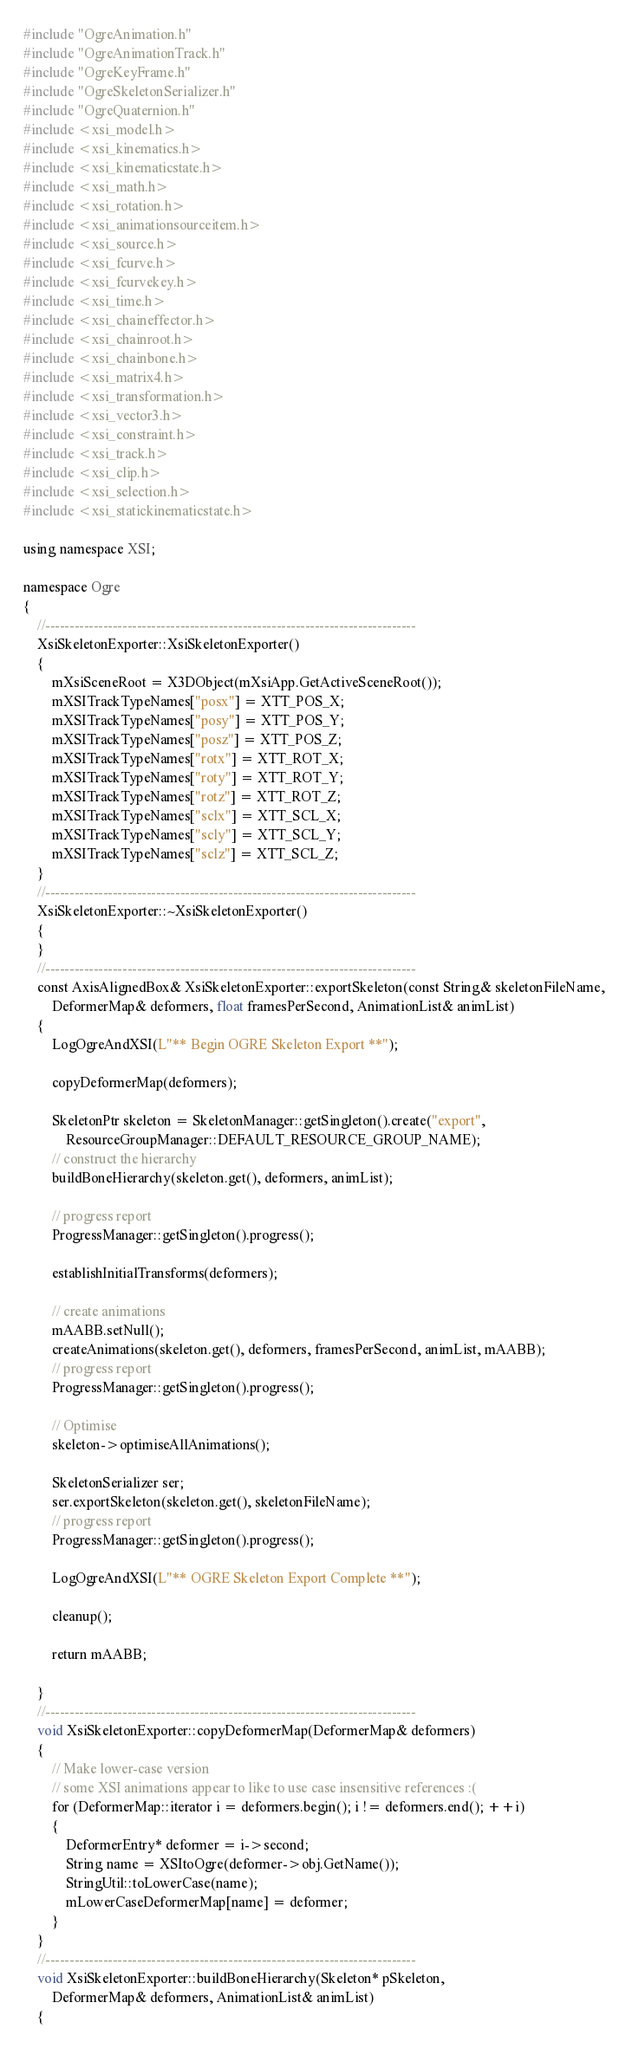Convert code to text. <code><loc_0><loc_0><loc_500><loc_500><_C++_>#include "OgreAnimation.h"
#include "OgreAnimationTrack.h"
#include "OgreKeyFrame.h"
#include "OgreSkeletonSerializer.h"
#include "OgreQuaternion.h"
#include <xsi_model.h>
#include <xsi_kinematics.h>
#include <xsi_kinematicstate.h>
#include <xsi_math.h>
#include <xsi_rotation.h>
#include <xsi_animationsourceitem.h>
#include <xsi_source.h>
#include <xsi_fcurve.h>
#include <xsi_fcurvekey.h>
#include <xsi_time.h>
#include <xsi_chaineffector.h>
#include <xsi_chainroot.h>
#include <xsi_chainbone.h>
#include <xsi_matrix4.h>
#include <xsi_transformation.h>
#include <xsi_vector3.h>
#include <xsi_constraint.h>
#include <xsi_track.h>
#include <xsi_clip.h>
#include <xsi_selection.h>
#include <xsi_statickinematicstate.h>

using namespace XSI;

namespace Ogre
{
	//-----------------------------------------------------------------------------
	XsiSkeletonExporter::XsiSkeletonExporter()
	{
		mXsiSceneRoot = X3DObject(mXsiApp.GetActiveSceneRoot());
		mXSITrackTypeNames["posx"] = XTT_POS_X;
		mXSITrackTypeNames["posy"] = XTT_POS_Y;
		mXSITrackTypeNames["posz"] = XTT_POS_Z;
		mXSITrackTypeNames["rotx"] = XTT_ROT_X;
		mXSITrackTypeNames["roty"] = XTT_ROT_Y;
		mXSITrackTypeNames["rotz"] = XTT_ROT_Z;
		mXSITrackTypeNames["sclx"] = XTT_SCL_X;
		mXSITrackTypeNames["scly"] = XTT_SCL_Y;
		mXSITrackTypeNames["sclz"] = XTT_SCL_Z;
	}
	//-----------------------------------------------------------------------------
	XsiSkeletonExporter::~XsiSkeletonExporter()
	{
	}
	//-----------------------------------------------------------------------------
	const AxisAlignedBox& XsiSkeletonExporter::exportSkeleton(const String& skeletonFileName, 
		DeformerMap& deformers, float framesPerSecond, AnimationList& animList)
	{
		LogOgreAndXSI(L"** Begin OGRE Skeleton Export **");

		copyDeformerMap(deformers);

		SkeletonPtr skeleton = SkeletonManager::getSingleton().create("export",
			ResourceGroupManager::DEFAULT_RESOURCE_GROUP_NAME);
		// construct the hierarchy
		buildBoneHierarchy(skeleton.get(), deformers, animList);

		// progress report
		ProgressManager::getSingleton().progress();

		establishInitialTransforms(deformers);

		// create animations 
		mAABB.setNull();
		createAnimations(skeleton.get(), deformers, framesPerSecond, animList, mAABB);
		// progress report
		ProgressManager::getSingleton().progress();

		// Optimise
		skeleton->optimiseAllAnimations();

		SkeletonSerializer ser;
		ser.exportSkeleton(skeleton.get(), skeletonFileName);
		// progress report
		ProgressManager::getSingleton().progress();

		LogOgreAndXSI(L"** OGRE Skeleton Export Complete **");

		cleanup();

		return mAABB;

	}
	//-----------------------------------------------------------------------------
	void XsiSkeletonExporter::copyDeformerMap(DeformerMap& deformers)
	{
		// Make lower-case version
		// some XSI animations appear to like to use case insensitive references :(
		for (DeformerMap::iterator i = deformers.begin(); i != deformers.end(); ++i)
		{
			DeformerEntry* deformer = i->second;
			String name = XSItoOgre(deformer->obj.GetName());
			StringUtil::toLowerCase(name);
			mLowerCaseDeformerMap[name] = deformer;
		}
	}
	//-----------------------------------------------------------------------------
	void XsiSkeletonExporter::buildBoneHierarchy(Skeleton* pSkeleton, 
		DeformerMap& deformers, AnimationList& animList)
	{</code> 